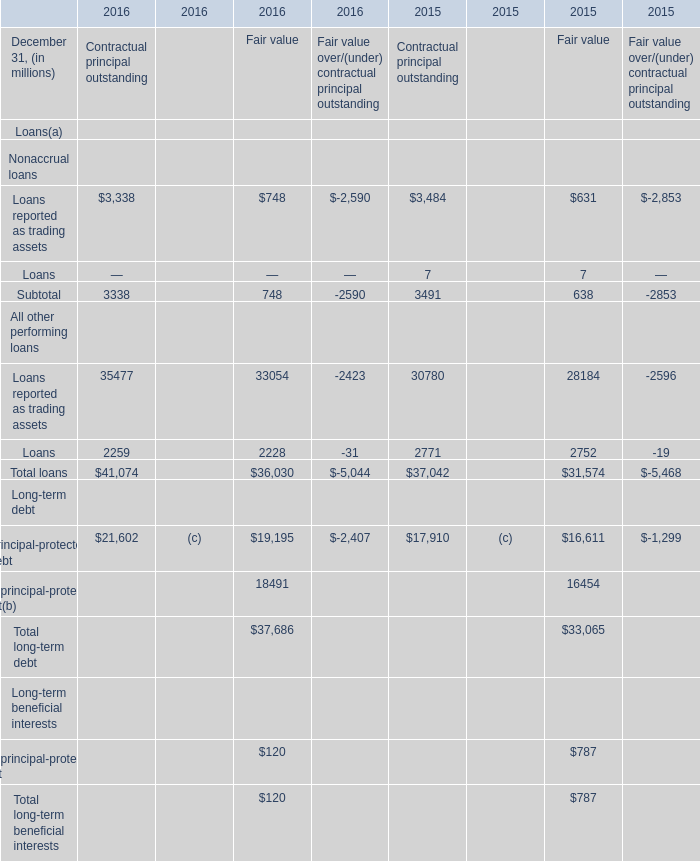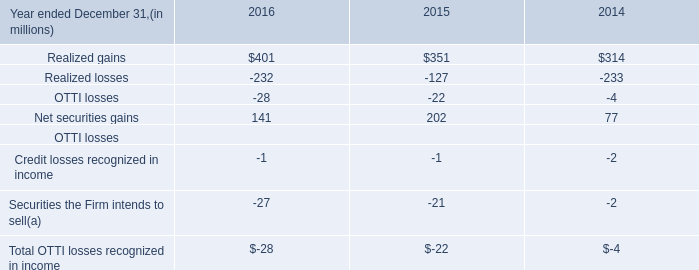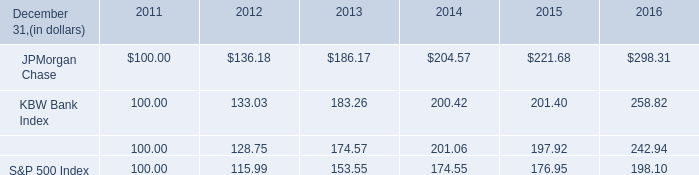What's the total amount of the Loans in the years where Subtotal greater than 0? (in million) 
Computations: (((((2259 + 2228) - 31) + 2771) + 2752) - 19)
Answer: 9960.0. 